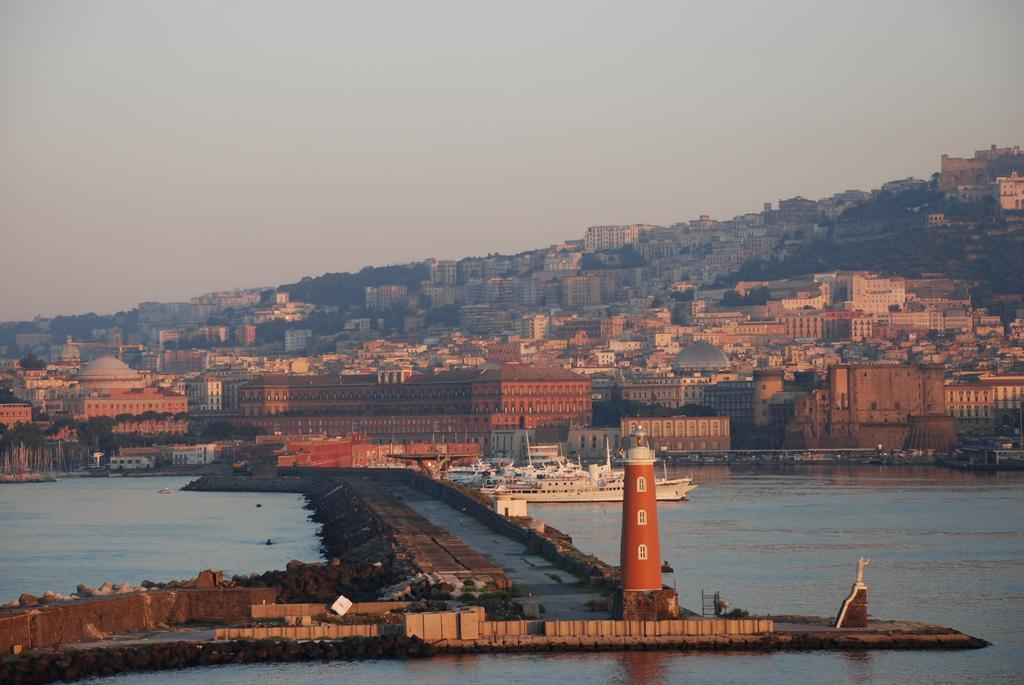What is the main structure in the image? There is a lighthouse in the image. What is the lighthouse surrounded by? The lighthouse is surrounded by water. What can be seen in the background of the image? The background of the image is the sky. How many beds are visible in the image? There are no beds present in the image; it features a lighthouse surrounded by water and the sky in the background. What type of apparatus is used to measure the height of the lighthouse in the image? There is no apparatus present in the image to measure the height of the lighthouse. 